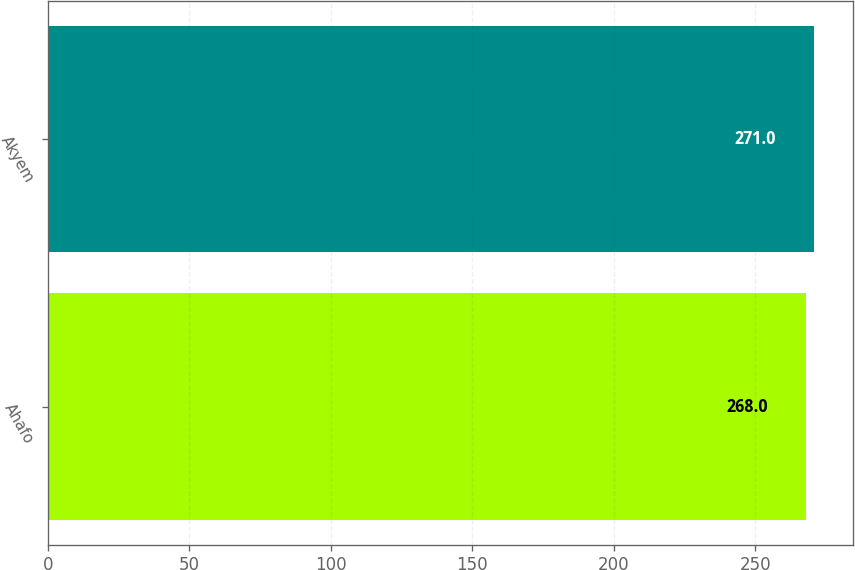Convert chart. <chart><loc_0><loc_0><loc_500><loc_500><bar_chart><fcel>Ahafo<fcel>Akyem<nl><fcel>268<fcel>271<nl></chart> 